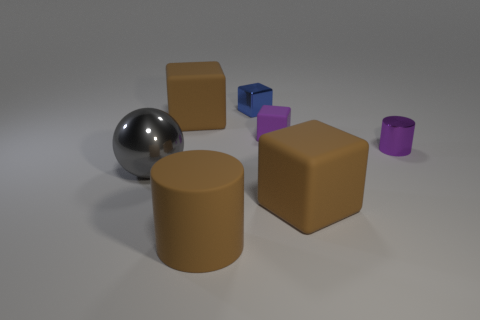What shape is the purple object that is the same material as the large sphere?
Your answer should be compact. Cylinder. What number of small things are shiny spheres or red rubber spheres?
Offer a terse response. 0. What number of other objects are there of the same color as the large metal ball?
Your answer should be very brief. 0. How many tiny things are on the left side of the tiny cube in front of the metal thing that is behind the purple metallic cylinder?
Keep it short and to the point. 1. There is a brown cube that is behind the gray shiny ball; does it have the same size as the tiny purple cylinder?
Provide a short and direct response. No. Is the number of large brown matte cylinders behind the purple cylinder less than the number of things that are behind the gray sphere?
Keep it short and to the point. Yes. Is the color of the big metal ball the same as the small metallic cube?
Provide a succinct answer. No. Is the number of metal things right of the sphere less than the number of matte blocks?
Make the answer very short. Yes. What material is the tiny cylinder that is the same color as the tiny matte cube?
Ensure brevity in your answer.  Metal. Is the material of the blue cube the same as the small cylinder?
Your response must be concise. Yes. 